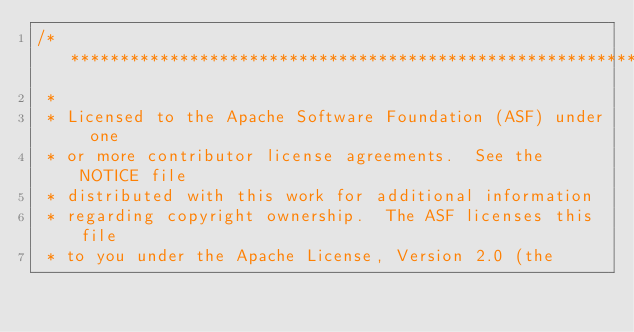<code> <loc_0><loc_0><loc_500><loc_500><_C++_>/**************************************************************
 * 
 * Licensed to the Apache Software Foundation (ASF) under one
 * or more contributor license agreements.  See the NOTICE file
 * distributed with this work for additional information
 * regarding copyright ownership.  The ASF licenses this file
 * to you under the Apache License, Version 2.0 (the</code> 